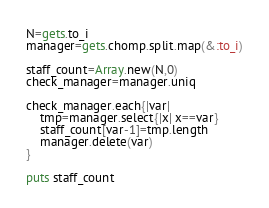Convert code to text. <code><loc_0><loc_0><loc_500><loc_500><_Ruby_>N=gets.to_i
manager=gets.chomp.split.map(&:to_i)

staff_count=Array.new(N,0)
check_manager=manager.uniq

check_manager.each{|var|
    tmp=manager.select{|x| x==var}
    staff_count[var-1]=tmp.length
    manager.delete(var)
}

puts staff_count</code> 